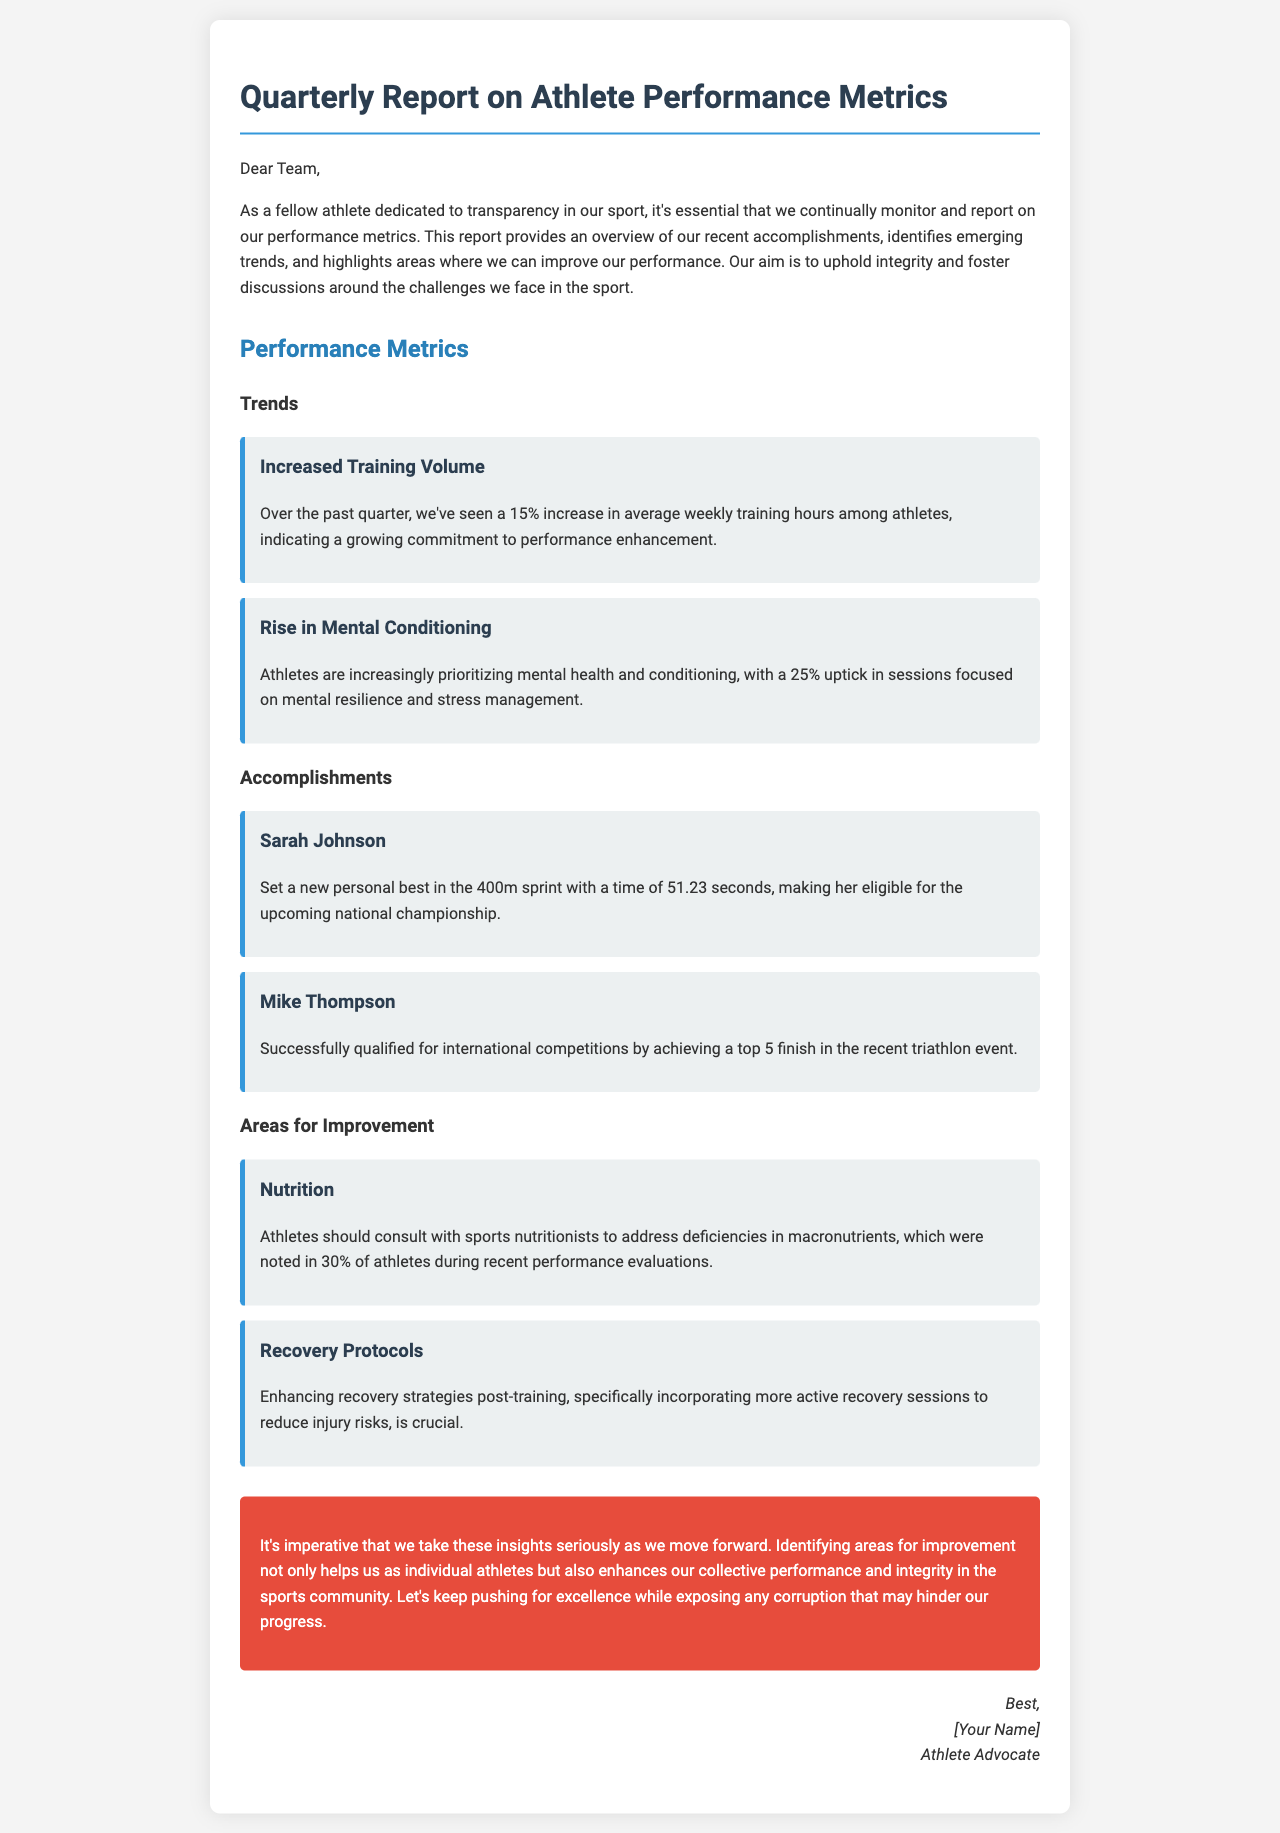What is the title of the report? The title of the report is prominently displayed at the beginning of the document.
Answer: Quarterly Report on Athlete Performance Metrics What percentage increase was noted in average weekly training hours? The document states that average weekly training hours have increased by a specific percentage, which is mentioned.
Answer: 15% Who set a new personal best in the 400m sprint? The report lists accomplishments, including the name of the athlete who achieved this milestone.
Answer: Sarah Johnson What area of athlete performance needs improvement according to the report? The report highlights specific areas for improvement, one of which is clearly specified.
Answer: Nutrition What was the percentage increase in sessions focused on mental resilience? The document includes a statistic regarding the rise in mental conditioning sessions among athletes.
Answer: 25% Identify the key recommendation for improving recovery strategies. The report emphasizes a particular strategy that athletes should adopt to enhance recovery.
Answer: Active recovery sessions What was the event at which Mike Thompson qualified for international competitions? The accomplishments section provides details on the event leading to Mike Thompson's qualification.
Answer: Triathlon event What is the conclusion's stance on addressing areas for improvement? The conclusion expresses a specific viewpoint about the importance of acknowledging areas for improvement.
Answer: Imperative 